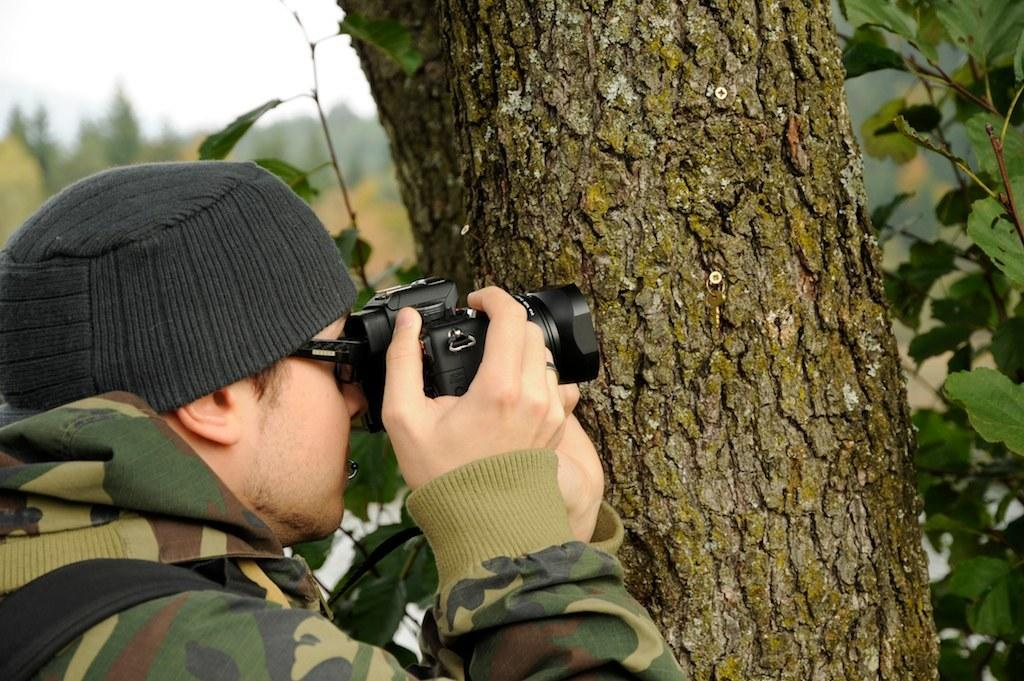Where was the image taken? The image is taken outdoors. Can you describe the man in the image? The man is wearing an army jacket and a black hat. What is the man holding in the image? The man is holding a black camera. What can be seen in front of the man? There are trees in front of the man. What is visible in the background of the image? The sky is visible in the image. What type of haircut does the man have in the image? There is no information about the man's haircut in the image. What is the name of the downtown street where the image was taken? The image was not taken in a downtown area, so there is no street name to provide. 